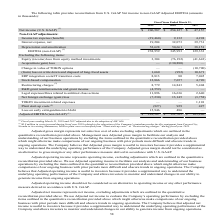According to Kemet Corporation's financial document, What was the net interest expense in 2019? According to the financial document, 19,204 (in thousands). The relevant text states: "Interest expense, net 19,204 32,073 39,731..." Also, What was the depreciation and amortization in 2017? According to the financial document, 38,151 (in thousands). The relevant text states: "Depreciation and amortization 52,628 50,661 38,151..." Also, Which years does the table provide information for the reconciliation from U.S. GAAP Net income to non-GAAP Adjusted EBITDA? The document contains multiple relevant values: 2019, 2018, 2017. From the document: "2019 2018 2017 2019 2018 2017 2019 2018 2017..." Also, can you calculate: What was the change in the Net foreign exchange (gain) loss between 2017 and 2018? Based on the calculation: 13,145-(-3,758), the result is 16903 (in thousands). This is based on the information: "Net foreign exchange (gain) loss (7,230) 13,145 (3,758) Net foreign exchange (gain) loss (7,230) 13,145 (3,758)..." The key data points involved are: 13,145, 3,758. Also, can you calculate: What was the change in the Loss on early extinguishment of debt between 2018 and 2019? Based on the calculation: 15,946-486, the result is 15460 (in thousands). This is based on the information: "Loss on early extinguishment of debt 15,946 486 — Loss on early extinguishment of debt 15,946 486 —..." The key data points involved are: 15,946, 486. Also, can you calculate: What was the percentage change in the net interest expense between 2018 and 2019? To answer this question, I need to perform calculations using the financial data. The calculation is: (19,204-32,073)/32,073, which equals -40.12 (percentage). This is based on the information: "Interest expense, net 19,204 32,073 39,731 Interest expense, net 19,204 32,073 39,731..." The key data points involved are: 19,204, 32,073. 